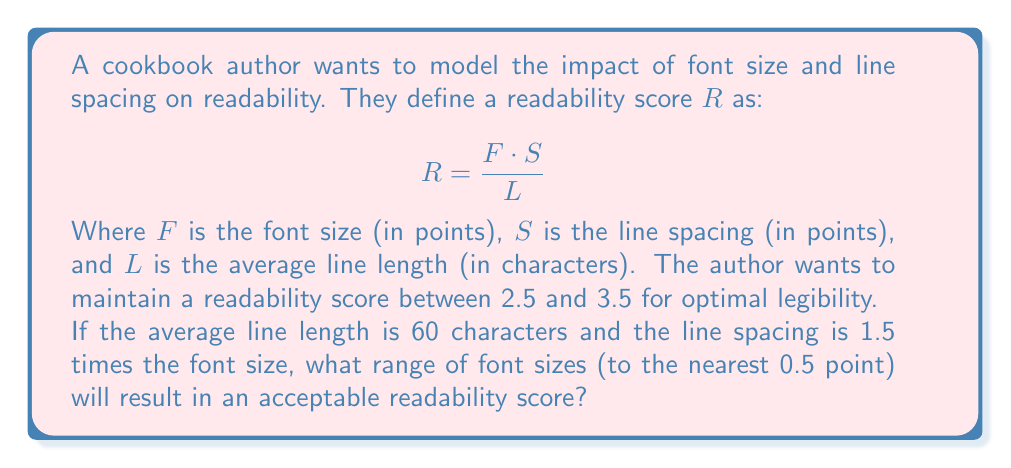Give your solution to this math problem. Let's approach this step-by-step:

1) We're given that $S = 1.5F$ and $L = 60$.

2) Substituting these into the readability formula:

   $$R = \frac{F \cdot (1.5F)}{60} = \frac{1.5F^2}{60}$$

3) We want $R$ to be between 2.5 and 3.5. Let's set up two inequalities:

   $$2.5 \leq \frac{1.5F^2}{60} \leq 3.5$$

4) Multiply all parts by 60:

   $$150 \leq 1.5F^2 \leq 210$$

5) Divide all parts by 1.5:

   $$100 \leq F^2 \leq 140$$

6) Take the square root of all parts:

   $$10 \leq F \leq \sqrt{140} \approx 11.83$$

7) Rounding to the nearest 0.5 point:
   The lower bound is already at 10.
   The upper bound rounds down to 11.5.

Therefore, the acceptable range of font sizes is from 10 to 11.5 points.
Answer: 10 to 11.5 points 